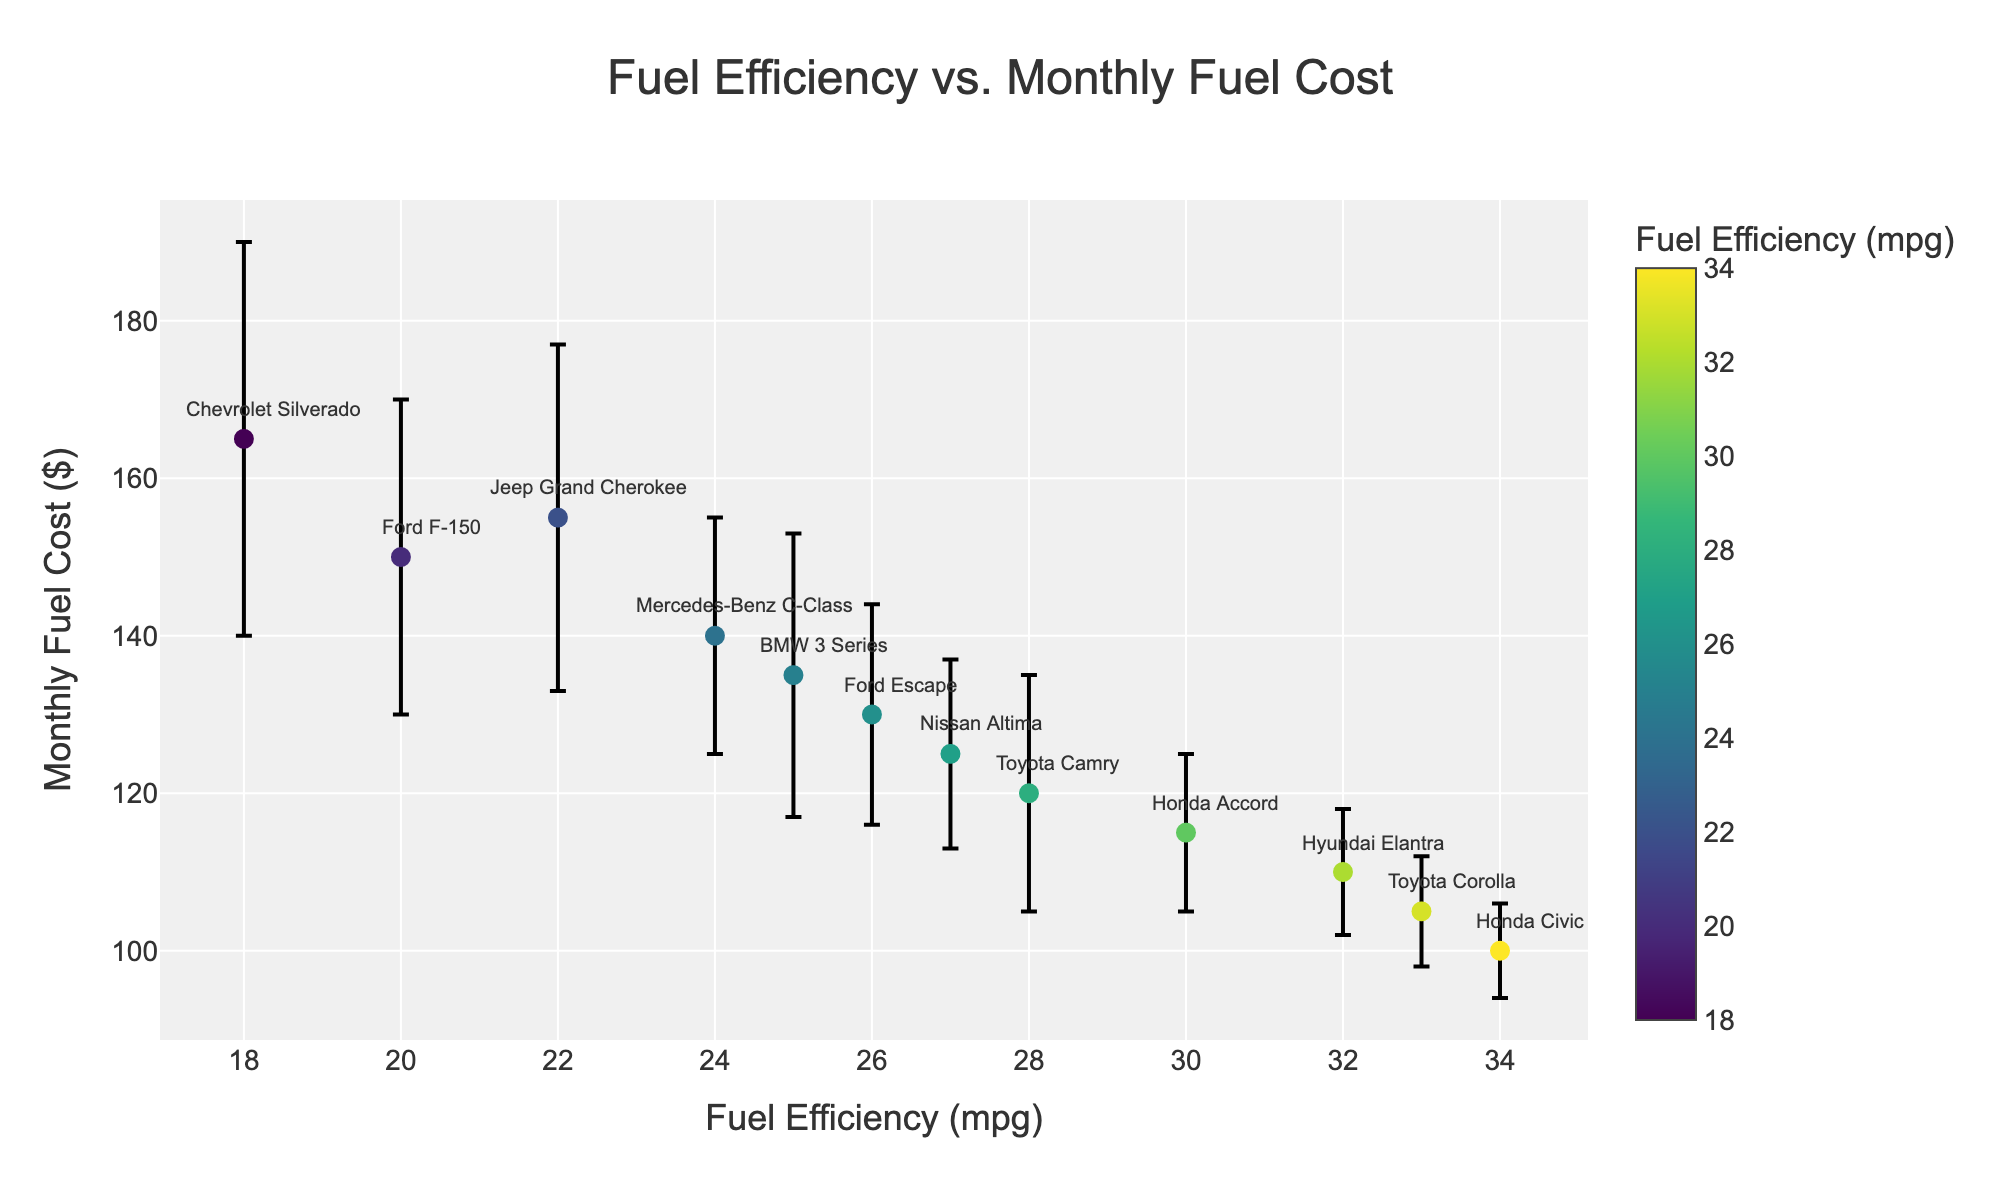What's the title of this scatter plot? The title of the plot is often located at the top center of the figure. In this case, the title is 'Fuel Efficiency vs. Monthly Fuel Cost'.
Answer: Fuel Efficiency vs. Monthly Fuel Cost Which car model has the lowest monthly fuel cost? The lowest data point on the y-axis represents the car model with the lowest monthly fuel cost. The car model, "Honda Civic," is at $100.
Answer: Honda Civic How many car models are represented in this figure? Each data point with unique labels represents a different car model. There are 12 distinct car models in the plot based on the labels.
Answer: 12 Which car model shows the highest variability in monthly fuel costs? The "error bars" denote the variability. The car model with the longest error bar on the y-axis is the "Chevrolet Silverado," indicating the highest variability ($25).
Answer: Chevrolet Silverado What is the relationship between fuel efficiency and monthly fuel cost? To determine the relationship, observe the trend of data points. Generally, higher fuel efficiency (higher mpg) corresponds to a lower monthly fuel cost. This indicates an inverse relationship.
Answer: Inverse relationship What is the fuel efficiency of the car model that has a monthly fuel cost of around $105? Look for the data point nearest to the $105 mark on the y-axis, which is "Toyota Corolla." The associated fuel efficiency is 33 mpg.
Answer: 33 mpg Compare the monthly fuel costs of Toyota Camry and Chevrolet Silverado. Which one is higher? Locate both "Toyota Camry" and "Chevrolet Silverado" on the plot. Toyota Camry’s monthly cost is $120, while Chevrolet Silverado's is $165. Therefore, Chevrolet Silverado’s monthly cost is higher.
Answer: Chevrolet Silverado Among the models listed, which two car models have the closest fuel efficiency? Compare the values of fuel efficiency for all models. "Honda Civic" and "Toyota Corolla" have very close fuel efficiencies at 34 mpg and 33 mpg, respectively.
Answer: Honda Civic and Toyota Corolla What is the average monthly fuel cost for the cars with more than 30 mpg fuel efficiency? Identify the cars with more than 30 mpg (Honda Accord, Hyundai Elantra, Toyota Corolla, Honda Civic). Their monthly fuel costs are $115, $110, $105, and $100. Calculate the average: (115 + 110 + 105 + 100) / 4 = $107.5.
Answer: $107.5 Which car model has both high variability and high monthly fuel cost? Look for data points with high monthly cost and long error bars. "Chevrolet Silverado" has both a high monthly cost ($165) and high variability ($25).
Answer: Chevrolet Silverado 